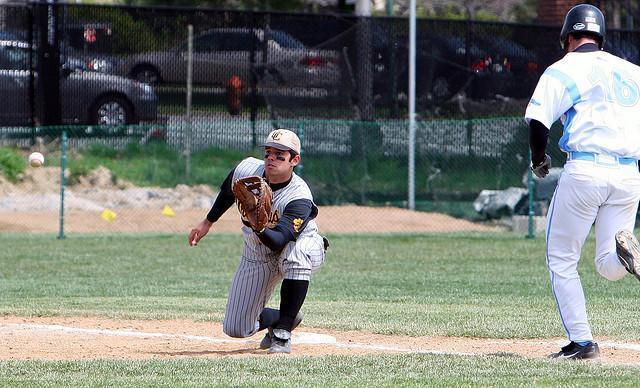How many people are in the photo?
Give a very brief answer. 2. How many cars can be seen?
Give a very brief answer. 3. 